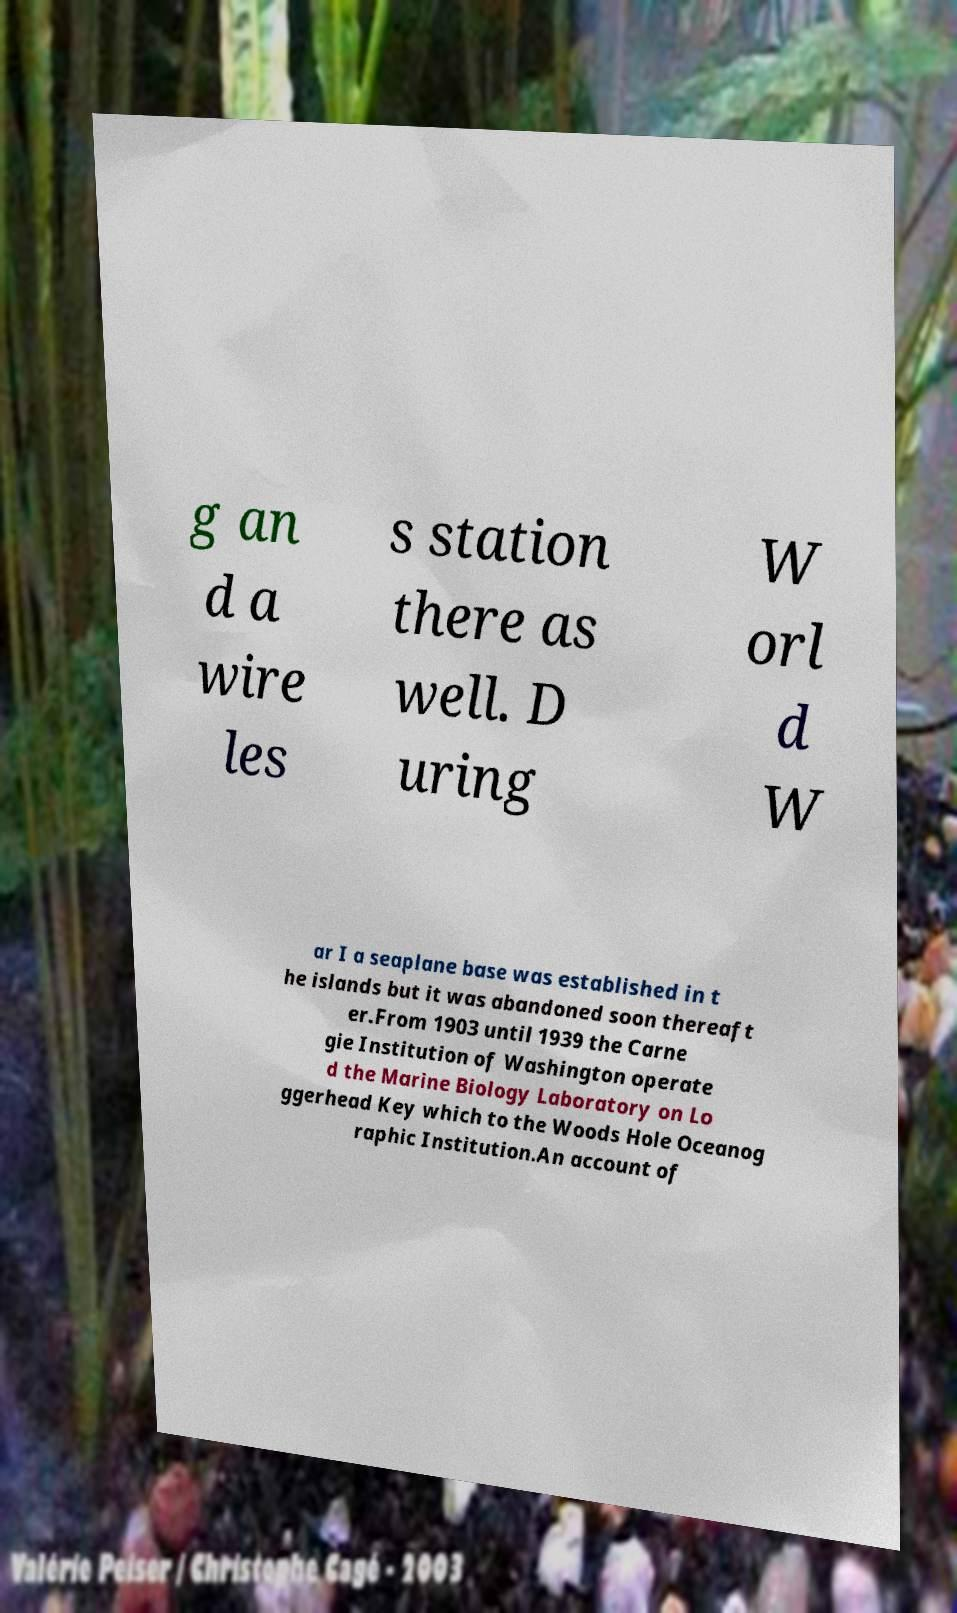I need the written content from this picture converted into text. Can you do that? g an d a wire les s station there as well. D uring W orl d W ar I a seaplane base was established in t he islands but it was abandoned soon thereaft er.From 1903 until 1939 the Carne gie Institution of Washington operate d the Marine Biology Laboratory on Lo ggerhead Key which to the Woods Hole Oceanog raphic Institution.An account of 